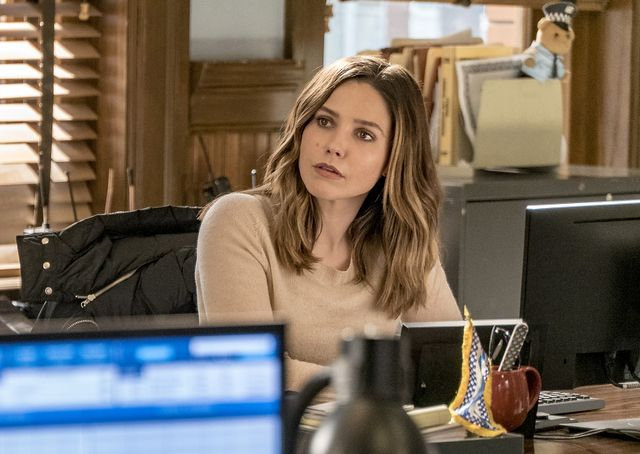Can you describe the mood of the person in this image? The individual in the image seems contemplative and serious. There's a certain intensity in her eyes that could reflect concern or deep thought, perhaps indicative of something important or challenging that she's dealing with at the moment. 